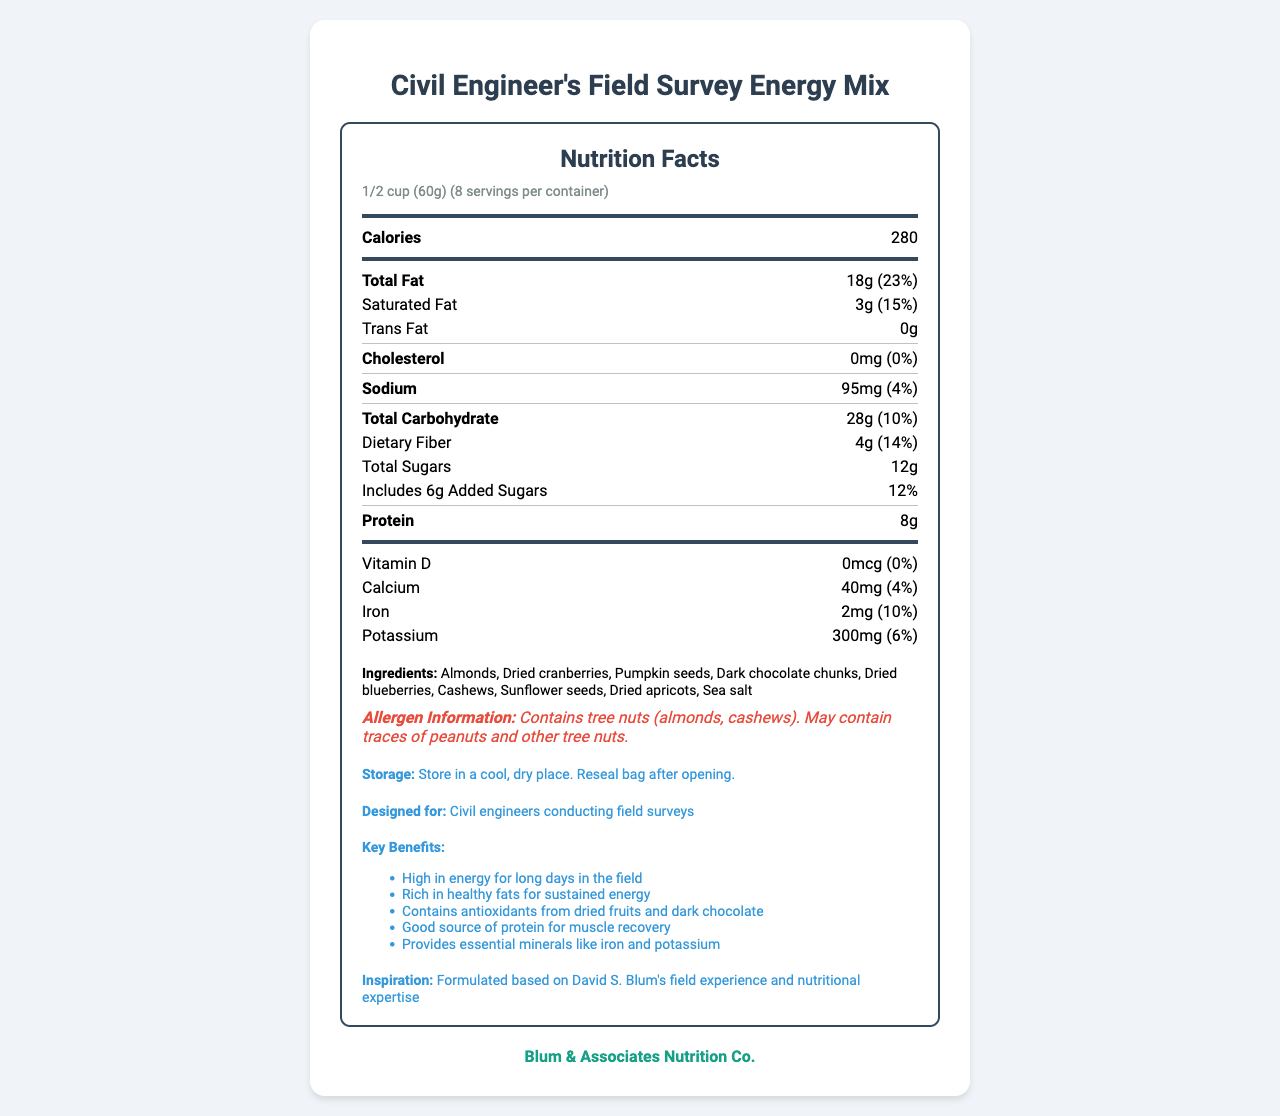what is the serving size? The serving size is prominently listed at the top of the Nutrition Facts Label.
Answer: 1/2 cup (60g) how many servings are in one container? The label states "8 servings per container" below the serving size information.
Answer: 8 what is the total fat content in a serving? The total fat amount per serving is listed as 18g in the nutrient breakdown.
Answer: 18g what percentage of the daily value of saturated fat does one serving contain? The saturated fat content contributes 15% to the daily value.
Answer: 15% how much protein is in each serving? The protein amount per serving is listed as 8g in the nutrient breakdown.
Answer: 8g how much iron does this product provide per serving? The iron content per serving is 2mg, which is 10% of the daily value.
Answer: 2mg (10% DV) does the product contain any added sugars? The label states that it includes 6g of added sugars, contributing 12% to the daily value.
Answer: Yes who is the "Civil Engineer’s Field Survey Energy Mix" designed for? The additional information explicitly states the product is designed for civil engineers conducting field surveys.
Answer: Civil engineers conducting field surveys what type of allergen information is provided? The allergen information specifies the presence of tree nuts and possible traces of other nuts.
Answer: Contains tree nuts (almonds, cashews). May contain traces of peanuts and other tree nuts. what organization manufactures this product? The manufacturer is listed as Blum & Associates Nutrition Co.
Answer: Blum & Associates Nutrition Co. which of the following is a key benefit of the product? I. High in energy II. Rich in healthy fats III. Contains antioxidants IV. Low in sodium The key benefits listed include high energy, rich in healthy fats, and containing antioxidants, but not low in sodium.
Answer: I, II, III how many grams of dietary fiber does this product have per serving? The dietary fiber content per serving is listed as 4g.
Answer: 4g does each serving of the trail mix contain any cholesterol? The label lists 0mg of cholesterol per serving.
Answer: No which ingredient is not mentioned in the ingredient list? A. Almonds B. Raisins C. Dried apricots D. Pumpkin seeds Raisins are not mentioned in the ingredients, whereas almonds, dried apricots, and pumpkin seeds are.
Answer: B does the product contain any calcium? The label indicates that each serving contains 40mg of calcium, which is 4% of the daily value.
Answer: Yes describe the main idea of the document. The label provides a comprehensive overview of the product's nutritional values and additional information to help consumers understand its benefits and usage.
Answer: The document is a Nutrition Facts Label for the "Civil Engineer's Field Survey Energy Mix," designed for civil engineers conducting field surveys. The label outlines the product's serving size, nutritional breakdown, ingredient list, allergen information, storage instructions, key benefits, and manufacturer details. how was the trail mix inspired? The additional information section mentions that the mix was formulated based on David S. Blum's field experience and nutritional expertise, but does not elaborate further.
Answer: Not enough information 